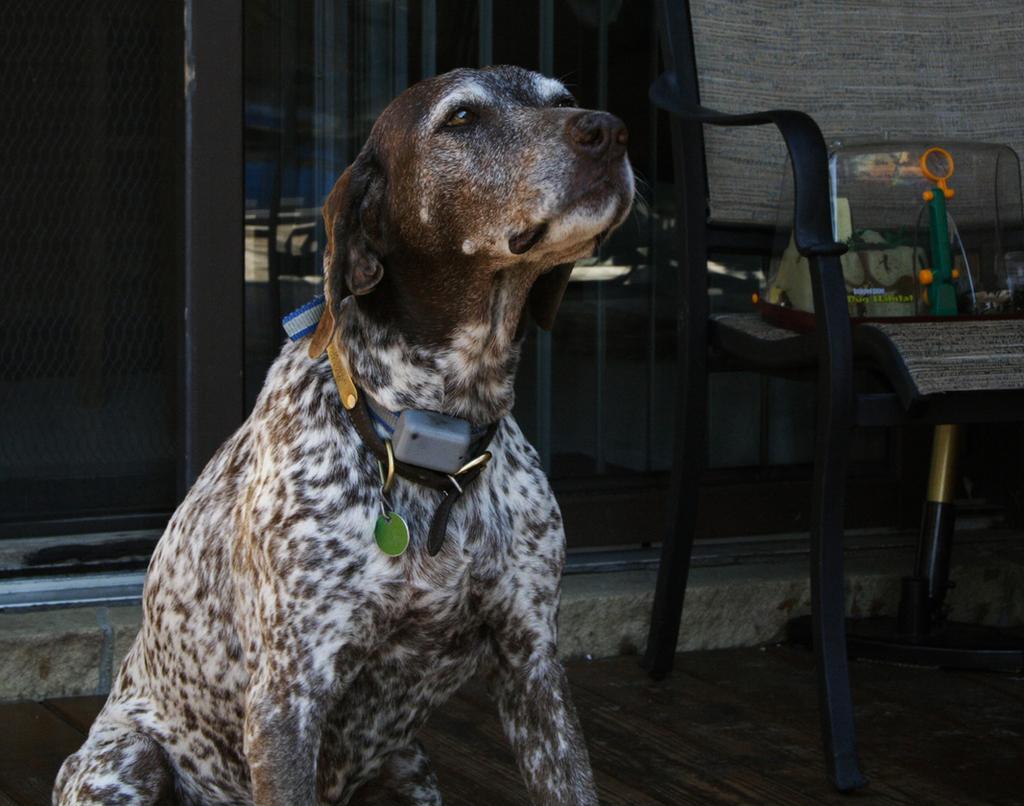What type of animal is in the image? There is an animal in the image, but the specific type cannot be determined from the provided facts. What is located on the right side of the image? There is a sitting bench on the right side of the image. What is placed on the sitting bench? There is an object on the sitting bench. What type of barrier is visible in the background of the image? There is a fence in the background of the image. What can be seen on the floor in the image? The floor is visible in the image, but no specific details about the floor can be determined from the provided facts. What grade is the animal in the image currently attending? There is no information about the animal's grade or education in the image. How many clams are visible on the sitting bench in the image? There are no clams visible in the image. 